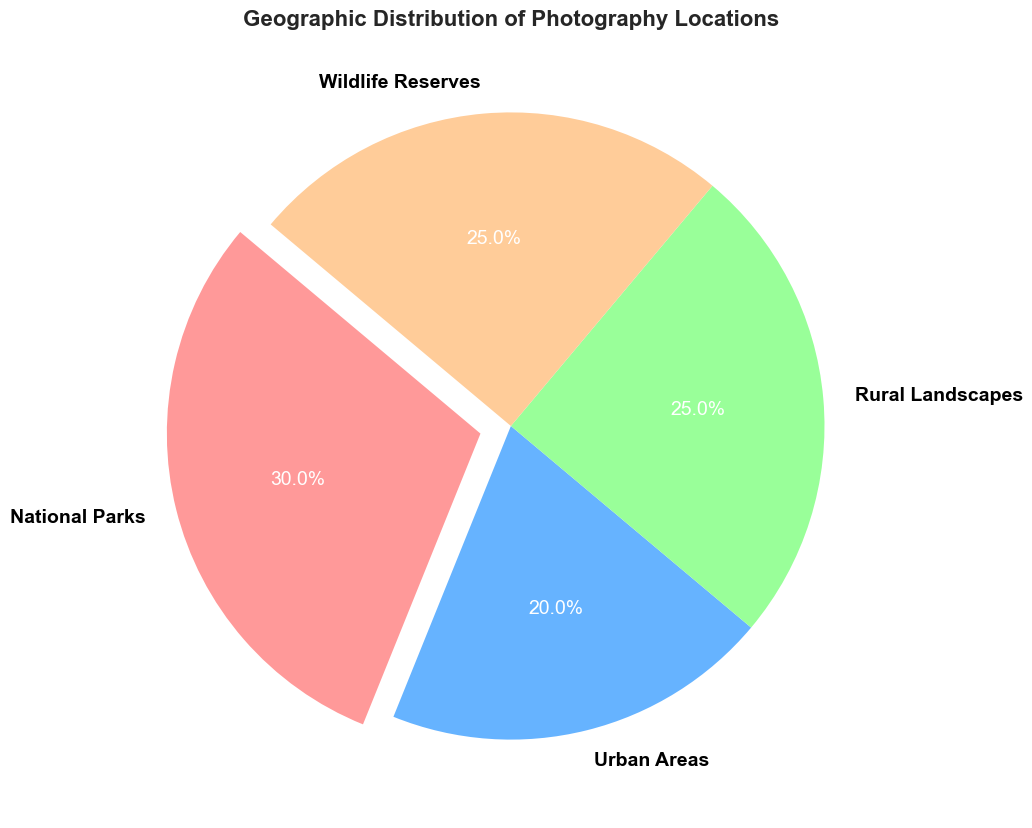What's the largest category in terms of percentage? The largest category can be identified by looking at the section of the pie chart with the biggest area. National Parks have the largest slice, which is 30%.
Answer: National Parks Which two categories have an equal distribution? By observing the pie chart, we can see that the slices for Rural Landscapes and Wildlife Reserves are equal. Both slices are annotated with the same percentage value of 25%.
Answer: Rural Landscapes and Wildlife Reserves What is the combined percentage for Urban Areas and Wildlife Reserves? To find the combined percentage, add the percentages of Urban Areas (20%) and Wildlife Reserves (25%). 20% + 25% = 45%.
Answer: 45% How much larger is the National Parks percentage compared to the Urban Areas percentage? Subtract the percentage for Urban Areas (20%) from the percentage for National Parks (30%). 30% - 20% = 10%.
Answer: 10% What colors are used to represent Rural Landscapes and Wildlife Reserves? By inspecting the pie chart, the colors assigned to each category are visible. Rural Landscapes are represented in green, and Wildlife Reserves are represented in orange.
Answer: Green and Orange What percentage of locations are outside of National Parks? Subtract the percentage of National Parks (30%) from the total percentage (100%). 100% - 30% = 70%.
Answer: 70% Is there any category with less than 20%? Looking at the pie chart, we see that all categories have percentages of 20% or higher. The smallest percentage shown is 20%, which corresponds to Urban Areas.
Answer: No What is the average percentage for all categories? To calculate the average, sum all percentages (30% + 20% + 25% + 25% = 100%) and divide by the number of categories (4). 100% / 4 = 25%.
Answer: 25% Which category is highlighted by being exploded from the pie chart? Identifying the section that sticks out from the pie chart, we see that National Parks is the highlighted category. It is distinguished by being exploded.
Answer: National Parks 